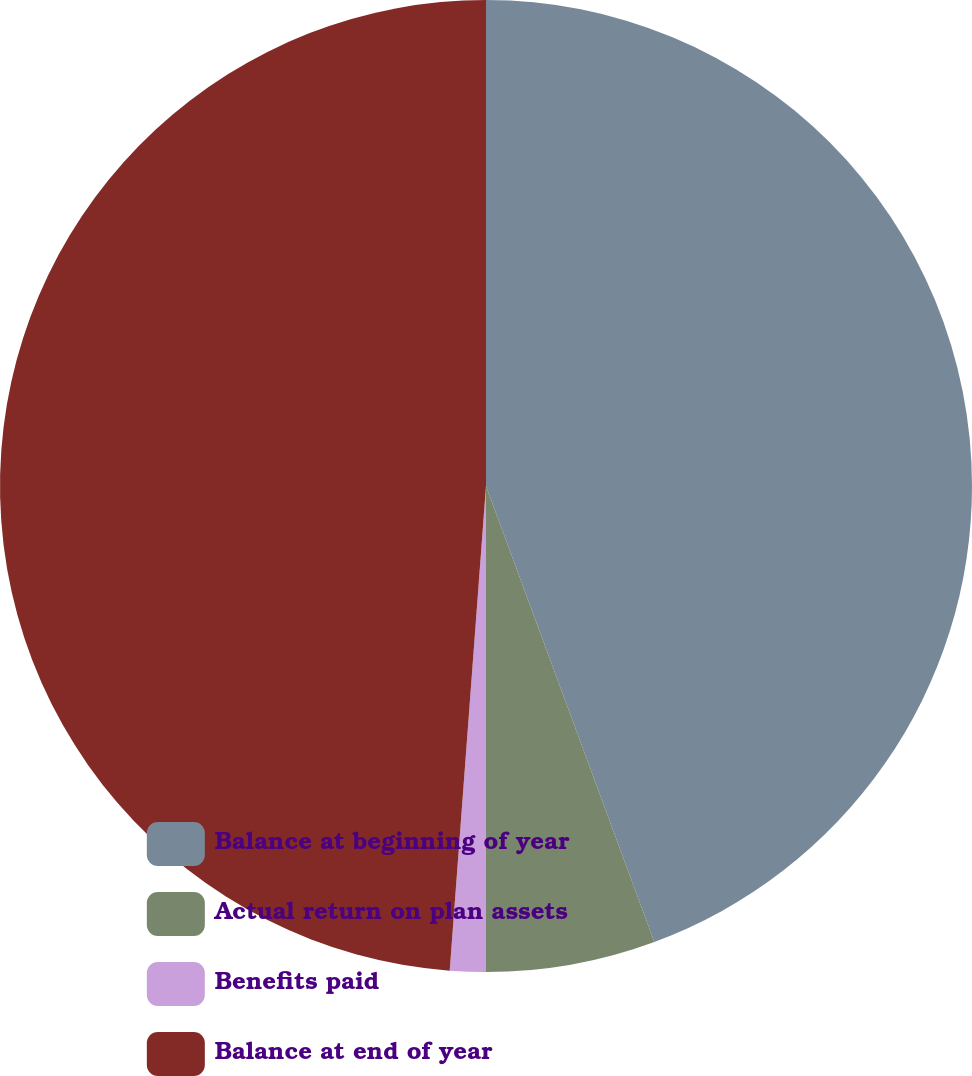Convert chart. <chart><loc_0><loc_0><loc_500><loc_500><pie_chart><fcel>Balance at beginning of year<fcel>Actual return on plan assets<fcel>Benefits paid<fcel>Balance at end of year<nl><fcel>44.37%<fcel>5.63%<fcel>1.19%<fcel>48.81%<nl></chart> 